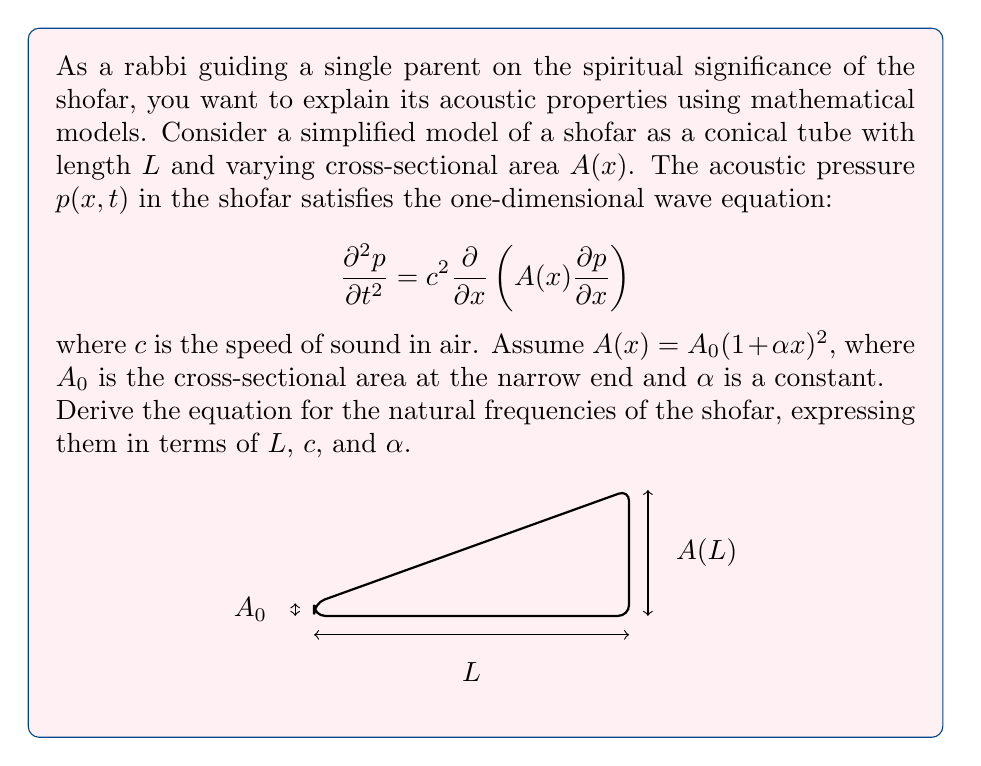Could you help me with this problem? To solve this problem, we'll follow these steps:

1) First, we need to separate variables. Let $p(x,t) = X(x)T(t)$.

2) Substituting this into the wave equation:

   $$X(x)T''(t) = c^2\frac{d}{dx}\left(A(x)\frac{dX}{dx}\right)T(t)$$

3) Dividing both sides by $X(x)T(t)$:

   $$\frac{T''(t)}{T(t)} = c^2\frac{1}{X(x)}\frac{d}{dx}\left(A(x)\frac{dX}{dx}\right) = -\omega^2$$

   Where $\omega^2$ is a separation constant.

4) This gives us two equations:
   
   $$T''(t) + \omega^2T(t) = 0$$
   $$\frac{d}{dx}\left(A(x)\frac{dX}{dx}\right) + \frac{\omega^2}{c^2}X(x) = 0$$

5) We focus on the spatial equation. Substituting $A(x) = A_0(1 + \alpha x)^2$:

   $$\frac{d}{dx}\left(A_0(1 + \alpha x)^2\frac{dX}{dx}\right) + \frac{\omega^2}{c^2}X = 0$$

6) Let $y = 1 + \alpha x$. Then $\frac{d}{dx} = \alpha\frac{d}{dy}$. The equation becomes:

   $$\alpha^2\frac{d}{dy}\left(y^2\frac{dX}{dy}\right) + \frac{\omega^2}{c^2}X = 0$$

7) This is Bessel's equation of order zero. The solution is:

   $$X(y) = AJ_0\left(\frac{\omega}{\alpha c}y\right) + BY_0\left(\frac{\omega}{\alpha c}y\right)$$

8) The boundary conditions are $X'(0) = 0$ (closed end) and $X(L) = 0$ (open end). Applying these:

   $$\frac{\omega}{\alpha c}J_1\left(\frac{\omega}{\alpha c}\right) = 0$$
   $$J_0\left(\frac{\omega}{\alpha c}(1 + \alpha L)\right) = 0$$

9) The natural frequencies are given by the roots of these equations. Let $z_n$ be the nth root of $J_0(z) = 0$. Then:

   $$\frac{\omega_n}{\alpha c}(1 + \alpha L) = z_n$$

10) Solving for $\omega_n$:

    $$\omega_n = \frac{\alpha c z_n}{1 + \alpha L}$$

This gives us the natural frequencies of the shofar.
Answer: $\omega_n = \frac{\alpha c z_n}{1 + \alpha L}$, where $z_n$ are roots of $J_0(z) = 0$ 